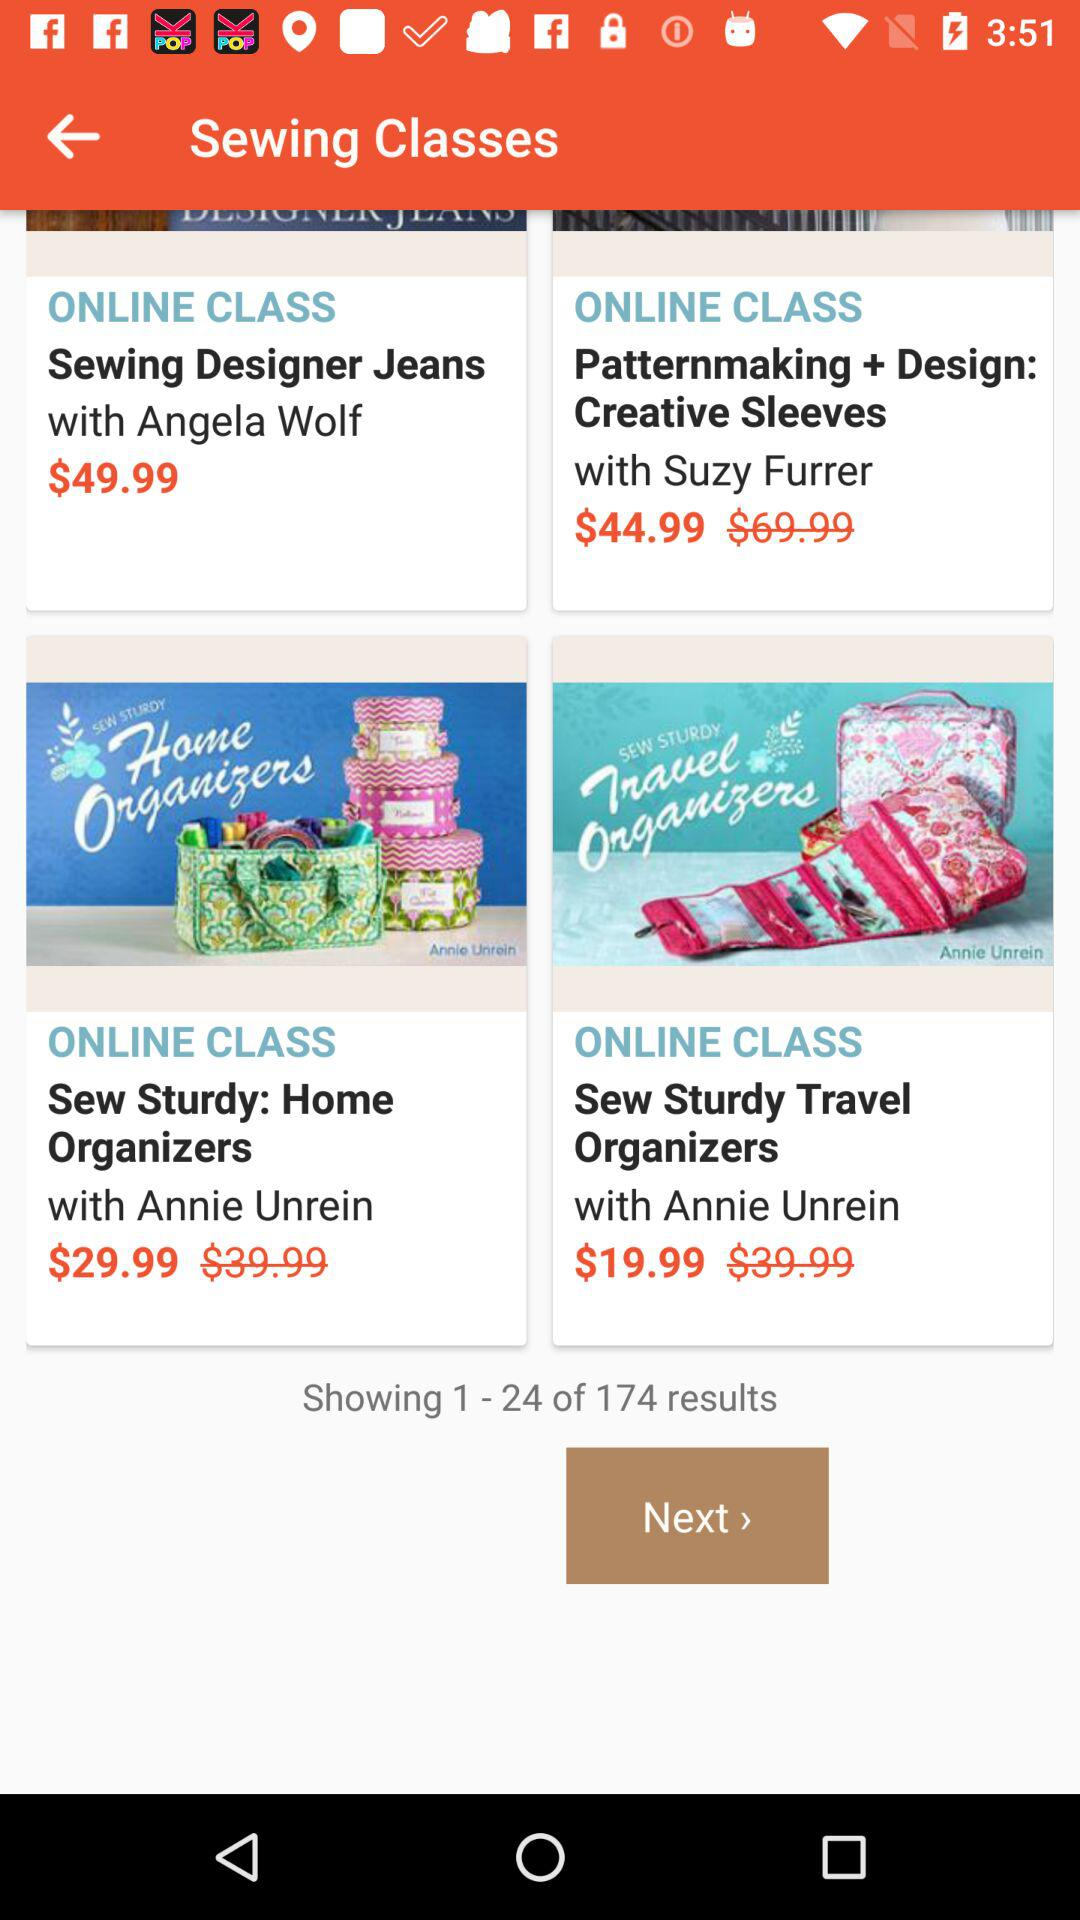What result is showing on the screen? The show result is 1-24 out of 174. 